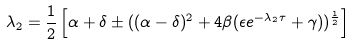<formula> <loc_0><loc_0><loc_500><loc_500>\lambda _ { 2 } = \frac { 1 } { 2 } \left [ \alpha + \delta \pm ( ( \alpha - \delta ) ^ { 2 } + 4 \beta ( \epsilon e ^ { - \lambda _ { 2 } \tau } + \gamma ) ) ^ { \frac { 1 } { 2 } } \right ]</formula> 